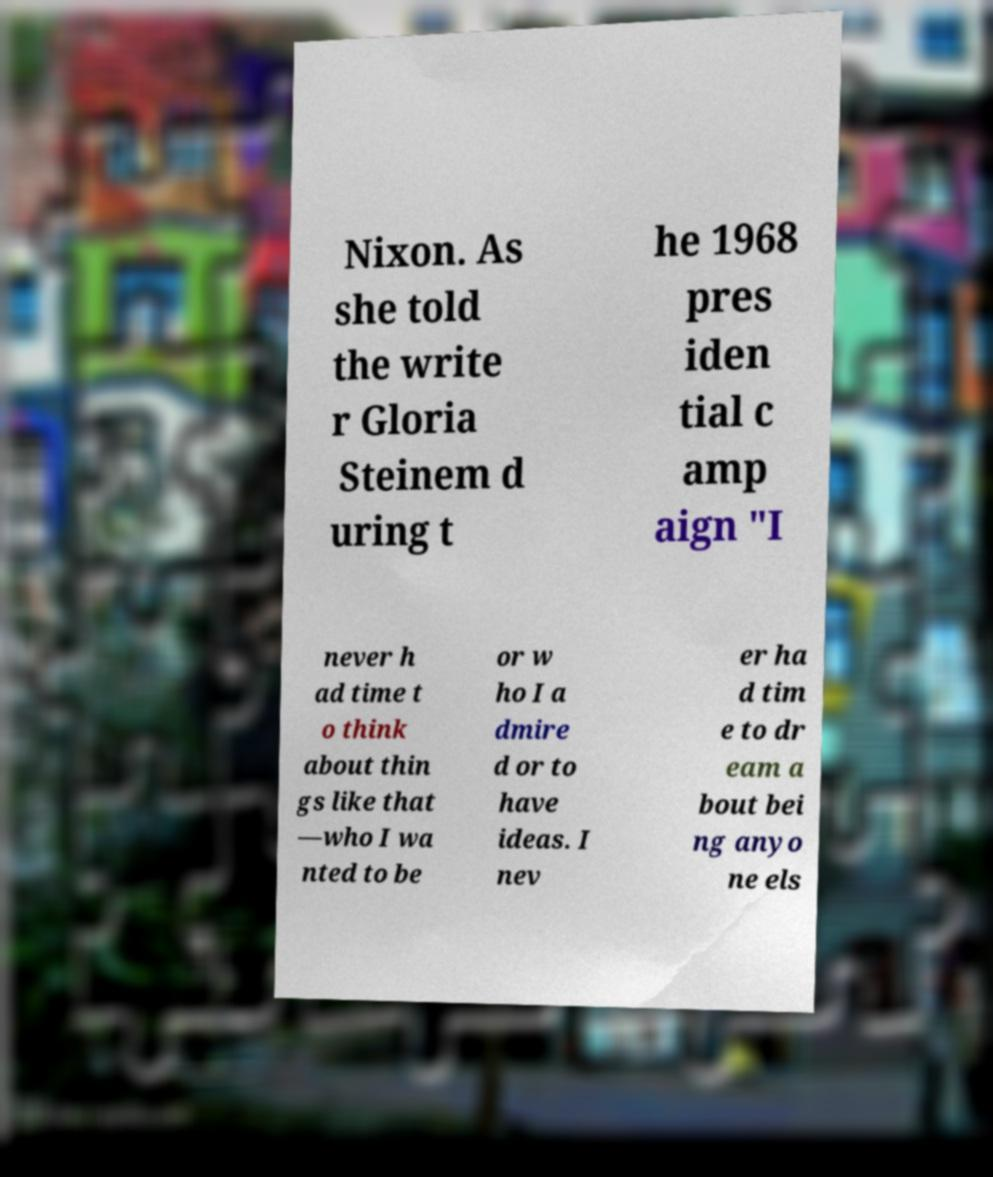Can you read and provide the text displayed in the image?This photo seems to have some interesting text. Can you extract and type it out for me? Nixon. As she told the write r Gloria Steinem d uring t he 1968 pres iden tial c amp aign "I never h ad time t o think about thin gs like that —who I wa nted to be or w ho I a dmire d or to have ideas. I nev er ha d tim e to dr eam a bout bei ng anyo ne els 